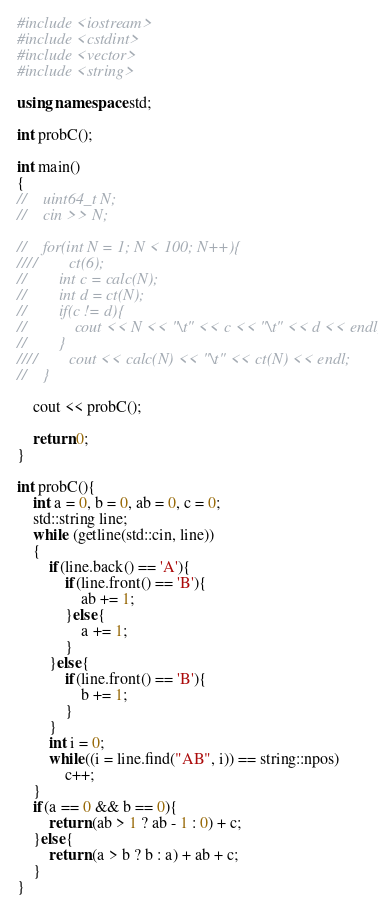<code> <loc_0><loc_0><loc_500><loc_500><_C++_>#include <iostream>
#include <cstdint>
#include <vector>
#include <string>

using namespace std;

int probC();

int main()
{
//    uint64_t N;
//    cin >> N;

//    for(int N = 1; N < 100; N++){
////        ct(6);
//        int c = calc(N);
//        int d = ct(N);
//        if(c != d){
//            cout << N << "\t" << c << "\t" << d << endl;
//        }
////        cout << calc(N) << "\t" << ct(N) << endl;
//    }

    cout << probC();

    return 0;
}

int probC(){
    int a = 0, b = 0, ab = 0, c = 0;
    std::string line;
    while (getline(std::cin, line))
    {
        if(line.back() == 'A'){
            if(line.front() == 'B'){
                ab += 1;
            }else{
                a += 1;
            }
        }else{
            if(line.front() == 'B'){
                b += 1;
            }
        }
        int i = 0;
        while((i = line.find("AB", i)) == string::npos)
            c++;
    }
    if(a == 0 && b == 0){
        return (ab > 1 ? ab - 1 : 0) + c;
    }else{
        return (a > b ? b : a) + ab + c;
    }
}</code> 